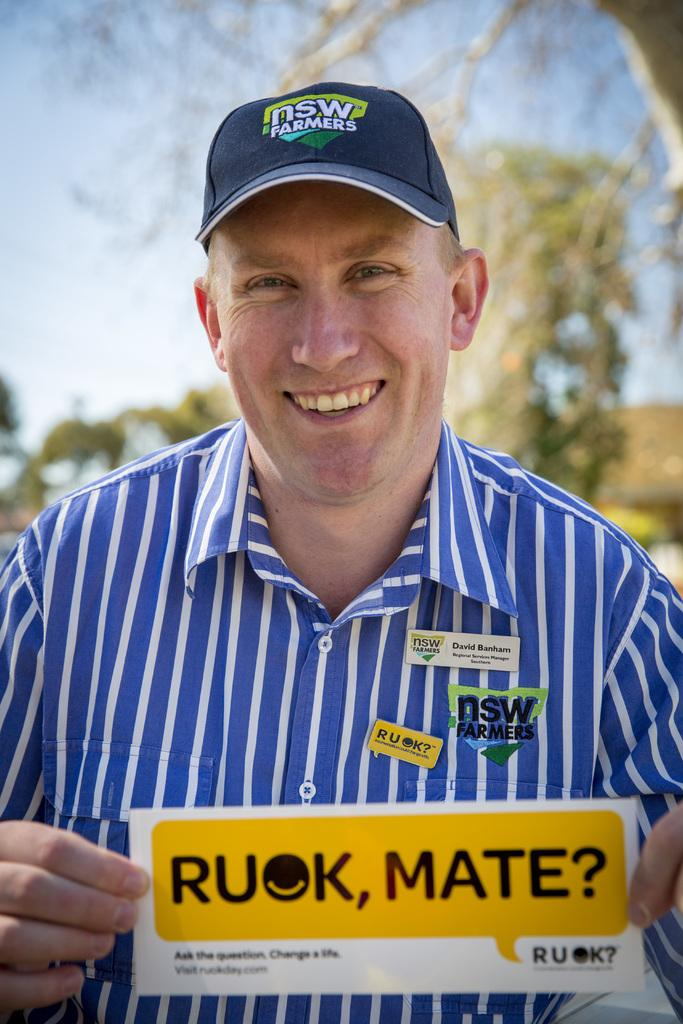<image>
Provide a brief description of the given image. Nsw farmers logo on a hat and shirt with a Ruok, Mate sign. 